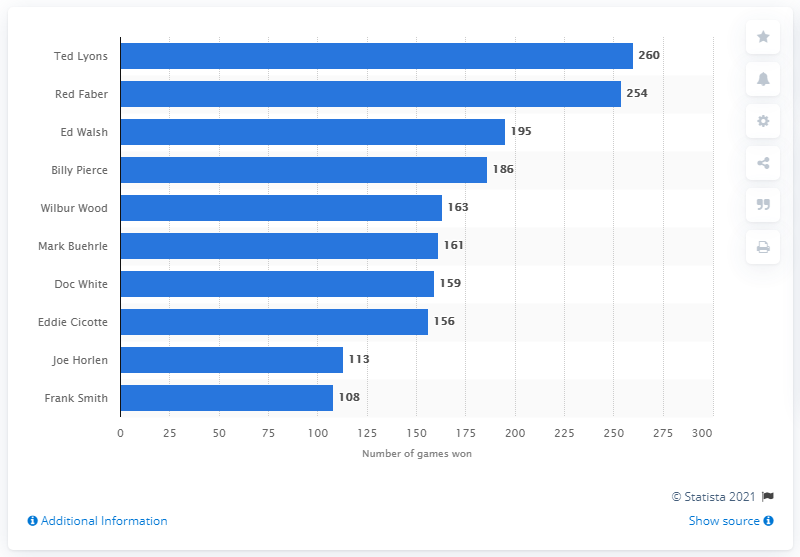Identify some key points in this picture. The individual who has won the most games in White Sox history is Ted Lyons. Ted Lyons has won the most games in White Sox history with 260 victories. 